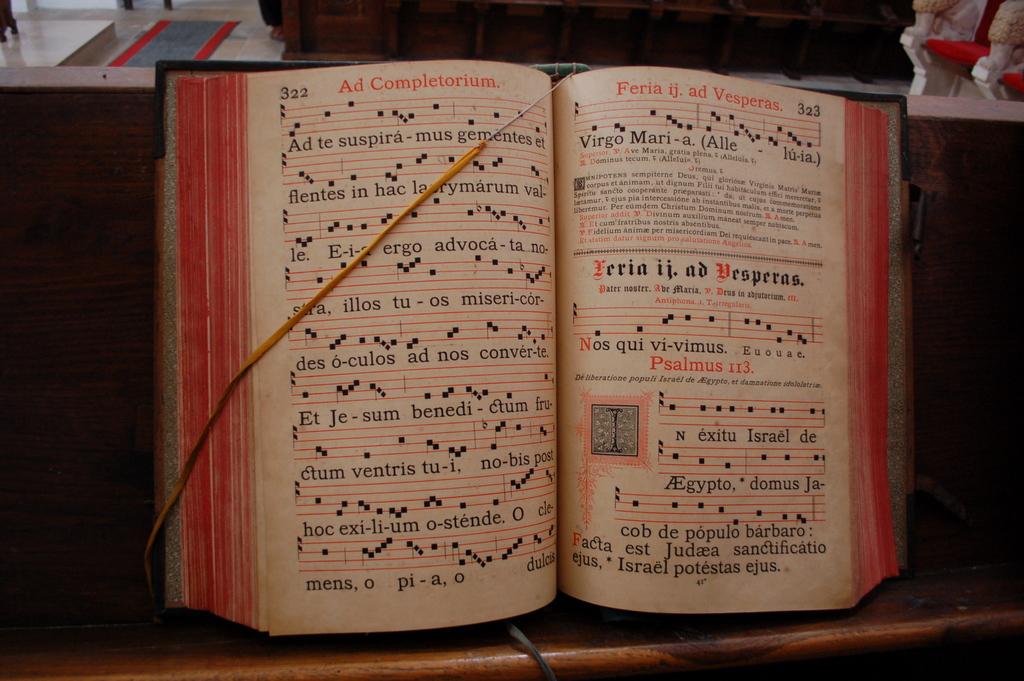Are the songs in the book in english?
Make the answer very short. No. What is the first song lyric?
Ensure brevity in your answer.  Unanswerable. 